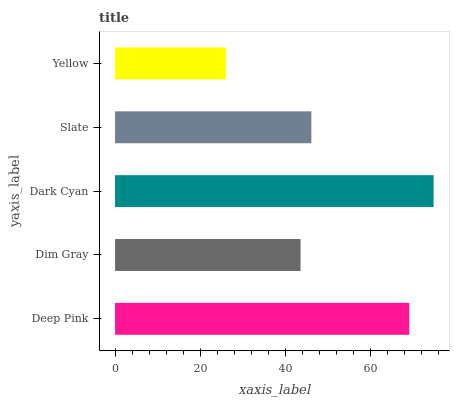Is Yellow the minimum?
Answer yes or no. Yes. Is Dark Cyan the maximum?
Answer yes or no. Yes. Is Dim Gray the minimum?
Answer yes or no. No. Is Dim Gray the maximum?
Answer yes or no. No. Is Deep Pink greater than Dim Gray?
Answer yes or no. Yes. Is Dim Gray less than Deep Pink?
Answer yes or no. Yes. Is Dim Gray greater than Deep Pink?
Answer yes or no. No. Is Deep Pink less than Dim Gray?
Answer yes or no. No. Is Slate the high median?
Answer yes or no. Yes. Is Slate the low median?
Answer yes or no. Yes. Is Deep Pink the high median?
Answer yes or no. No. Is Dim Gray the low median?
Answer yes or no. No. 